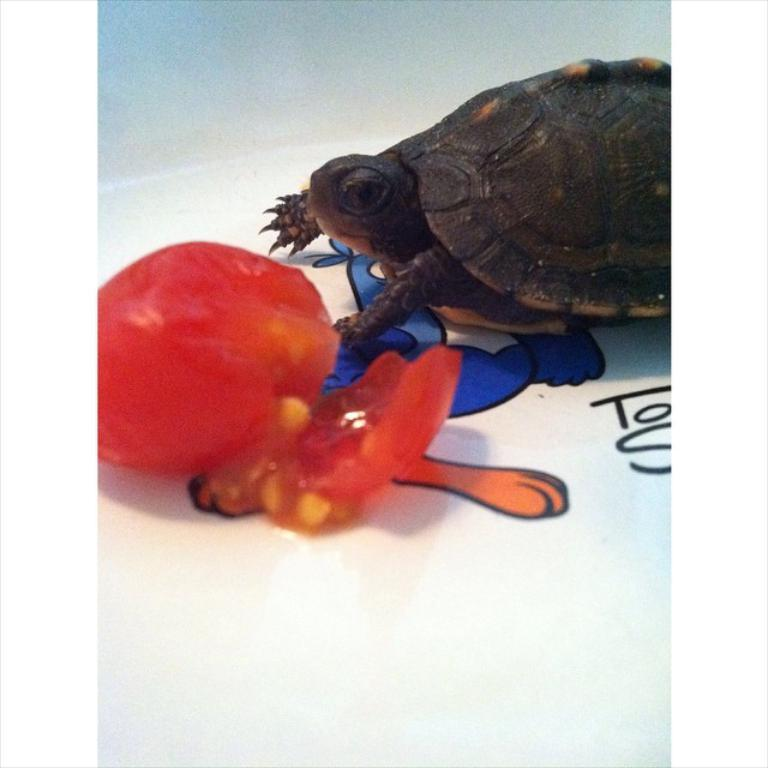What is one of the main objects in the image? There is a tomato in the image. What other living creature can be seen in the image? There is a turtle in the image. What is the color of the sheet on which the tomato and turtle are placed? The sheet is white in color. What else is present on the sheet besides the tomato and turtle? There is a painting on the sheet. What is the aftermath of the tomato and turtle's attack on the painting? There is no attack or aftermath mentioned in the image. The tomato, turtle, and painting are all depicted peacefully on the white sheet. 